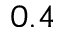<formula> <loc_0><loc_0><loc_500><loc_500>0 . 4</formula> 